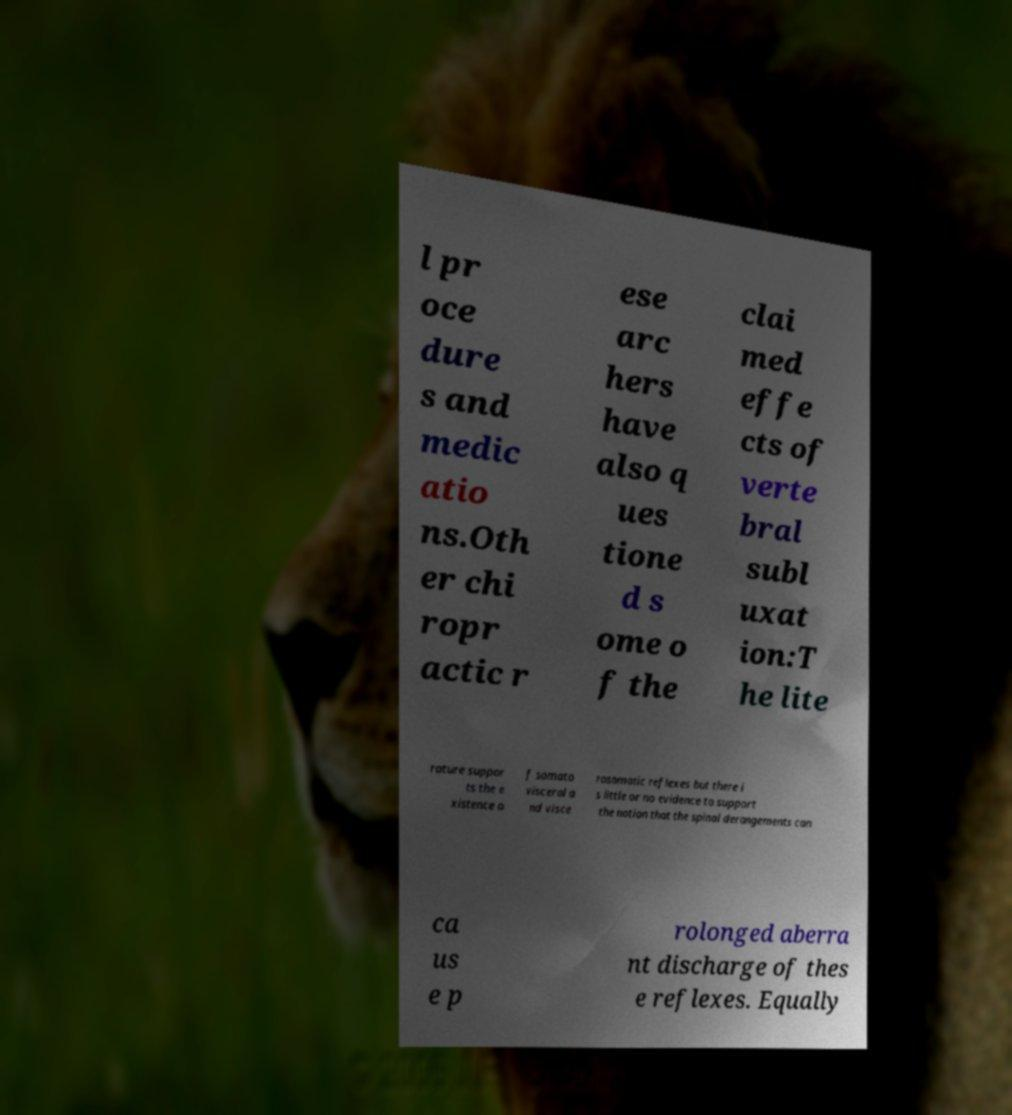What messages or text are displayed in this image? I need them in a readable, typed format. l pr oce dure s and medic atio ns.Oth er chi ropr actic r ese arc hers have also q ues tione d s ome o f the clai med effe cts of verte bral subl uxat ion:T he lite rature suppor ts the e xistence o f somato visceral a nd visce rosomatic reflexes but there i s little or no evidence to support the notion that the spinal derangements can ca us e p rolonged aberra nt discharge of thes e reflexes. Equally 